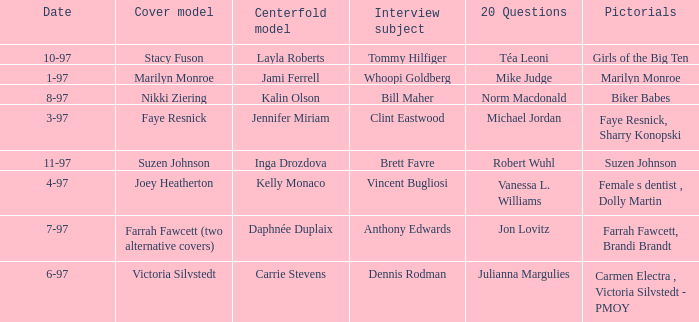What is the name of the cover model on 3-97? Faye Resnick. 